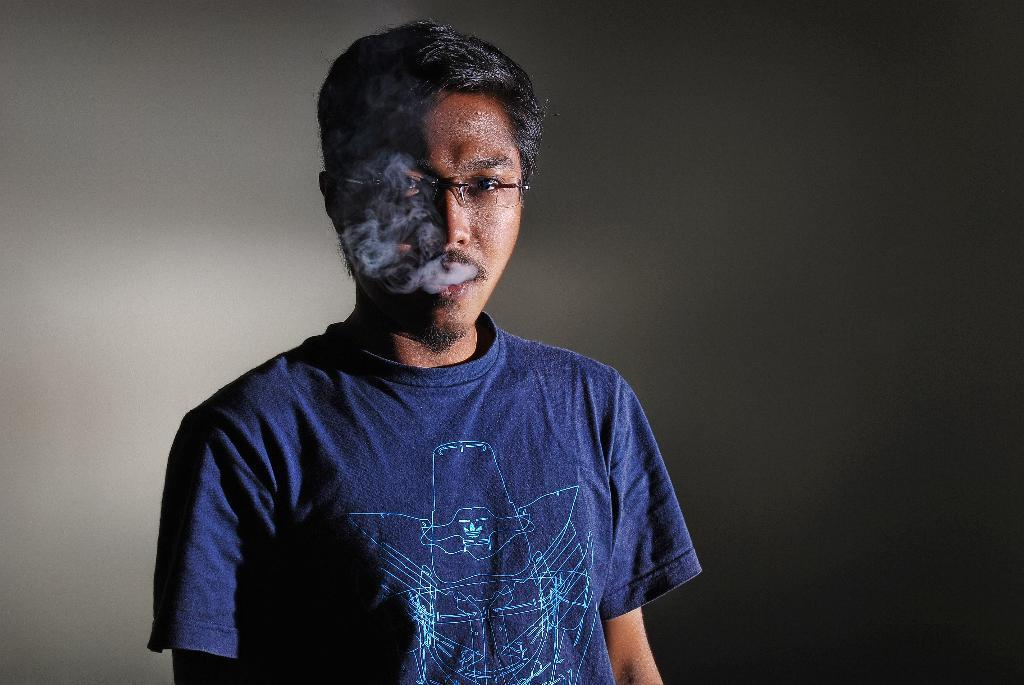Who is present in the image? There is a man in the image. What is the man doing in the image? Smoke is coming from the man's mouth. What can be seen in the background of the image? There is a wall in the background of the image. Can you see a lake in the background of the image? No, there is no lake present in the image. The background features a wall, not a lake. 